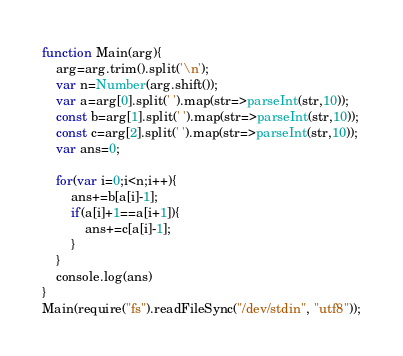Convert code to text. <code><loc_0><loc_0><loc_500><loc_500><_JavaScript_>function Main(arg){
    arg=arg.trim().split('\n');
    var n=Number(arg.shift());
    var a=arg[0].split(' ').map(str=>parseInt(str,10));
    const b=arg[1].split(' ').map(str=>parseInt(str,10));
    const c=arg[2].split(' ').map(str=>parseInt(str,10));
    var ans=0;

    for(var i=0;i<n;i++){
        ans+=b[a[i]-1];
        if(a[i]+1==a[i+1]){
            ans+=c[a[i]-1];
        }
    }
    console.log(ans)
}
Main(require("fs").readFileSync("/dev/stdin", "utf8"));</code> 